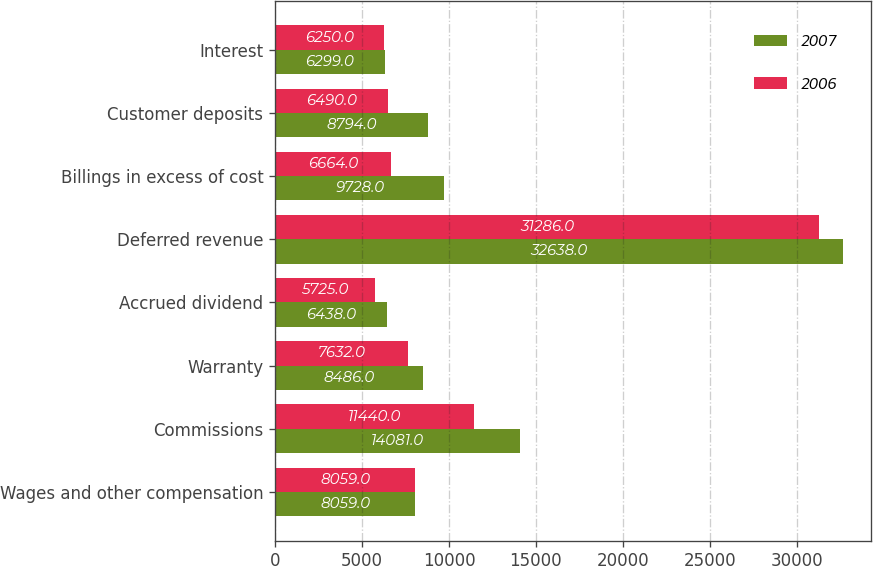Convert chart to OTSL. <chart><loc_0><loc_0><loc_500><loc_500><stacked_bar_chart><ecel><fcel>Wages and other compensation<fcel>Commissions<fcel>Warranty<fcel>Accrued dividend<fcel>Deferred revenue<fcel>Billings in excess of cost<fcel>Customer deposits<fcel>Interest<nl><fcel>2007<fcel>8059<fcel>14081<fcel>8486<fcel>6438<fcel>32638<fcel>9728<fcel>8794<fcel>6299<nl><fcel>2006<fcel>8059<fcel>11440<fcel>7632<fcel>5725<fcel>31286<fcel>6664<fcel>6490<fcel>6250<nl></chart> 